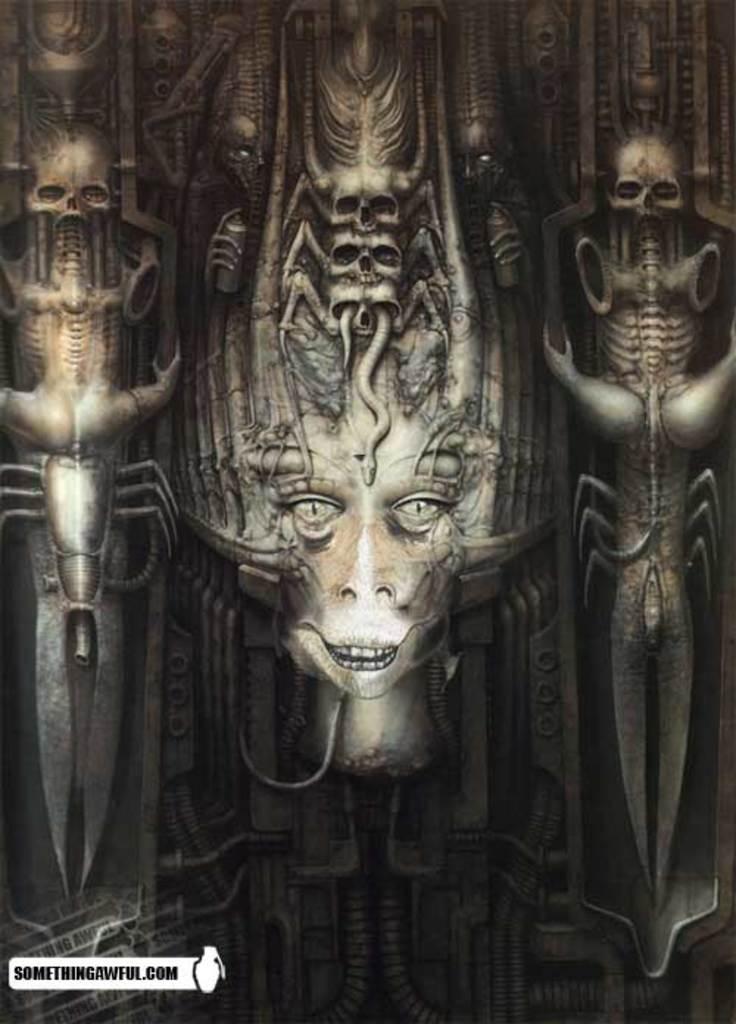Describe this image in one or two sentences. This is an edited image in which there are sculptures. 